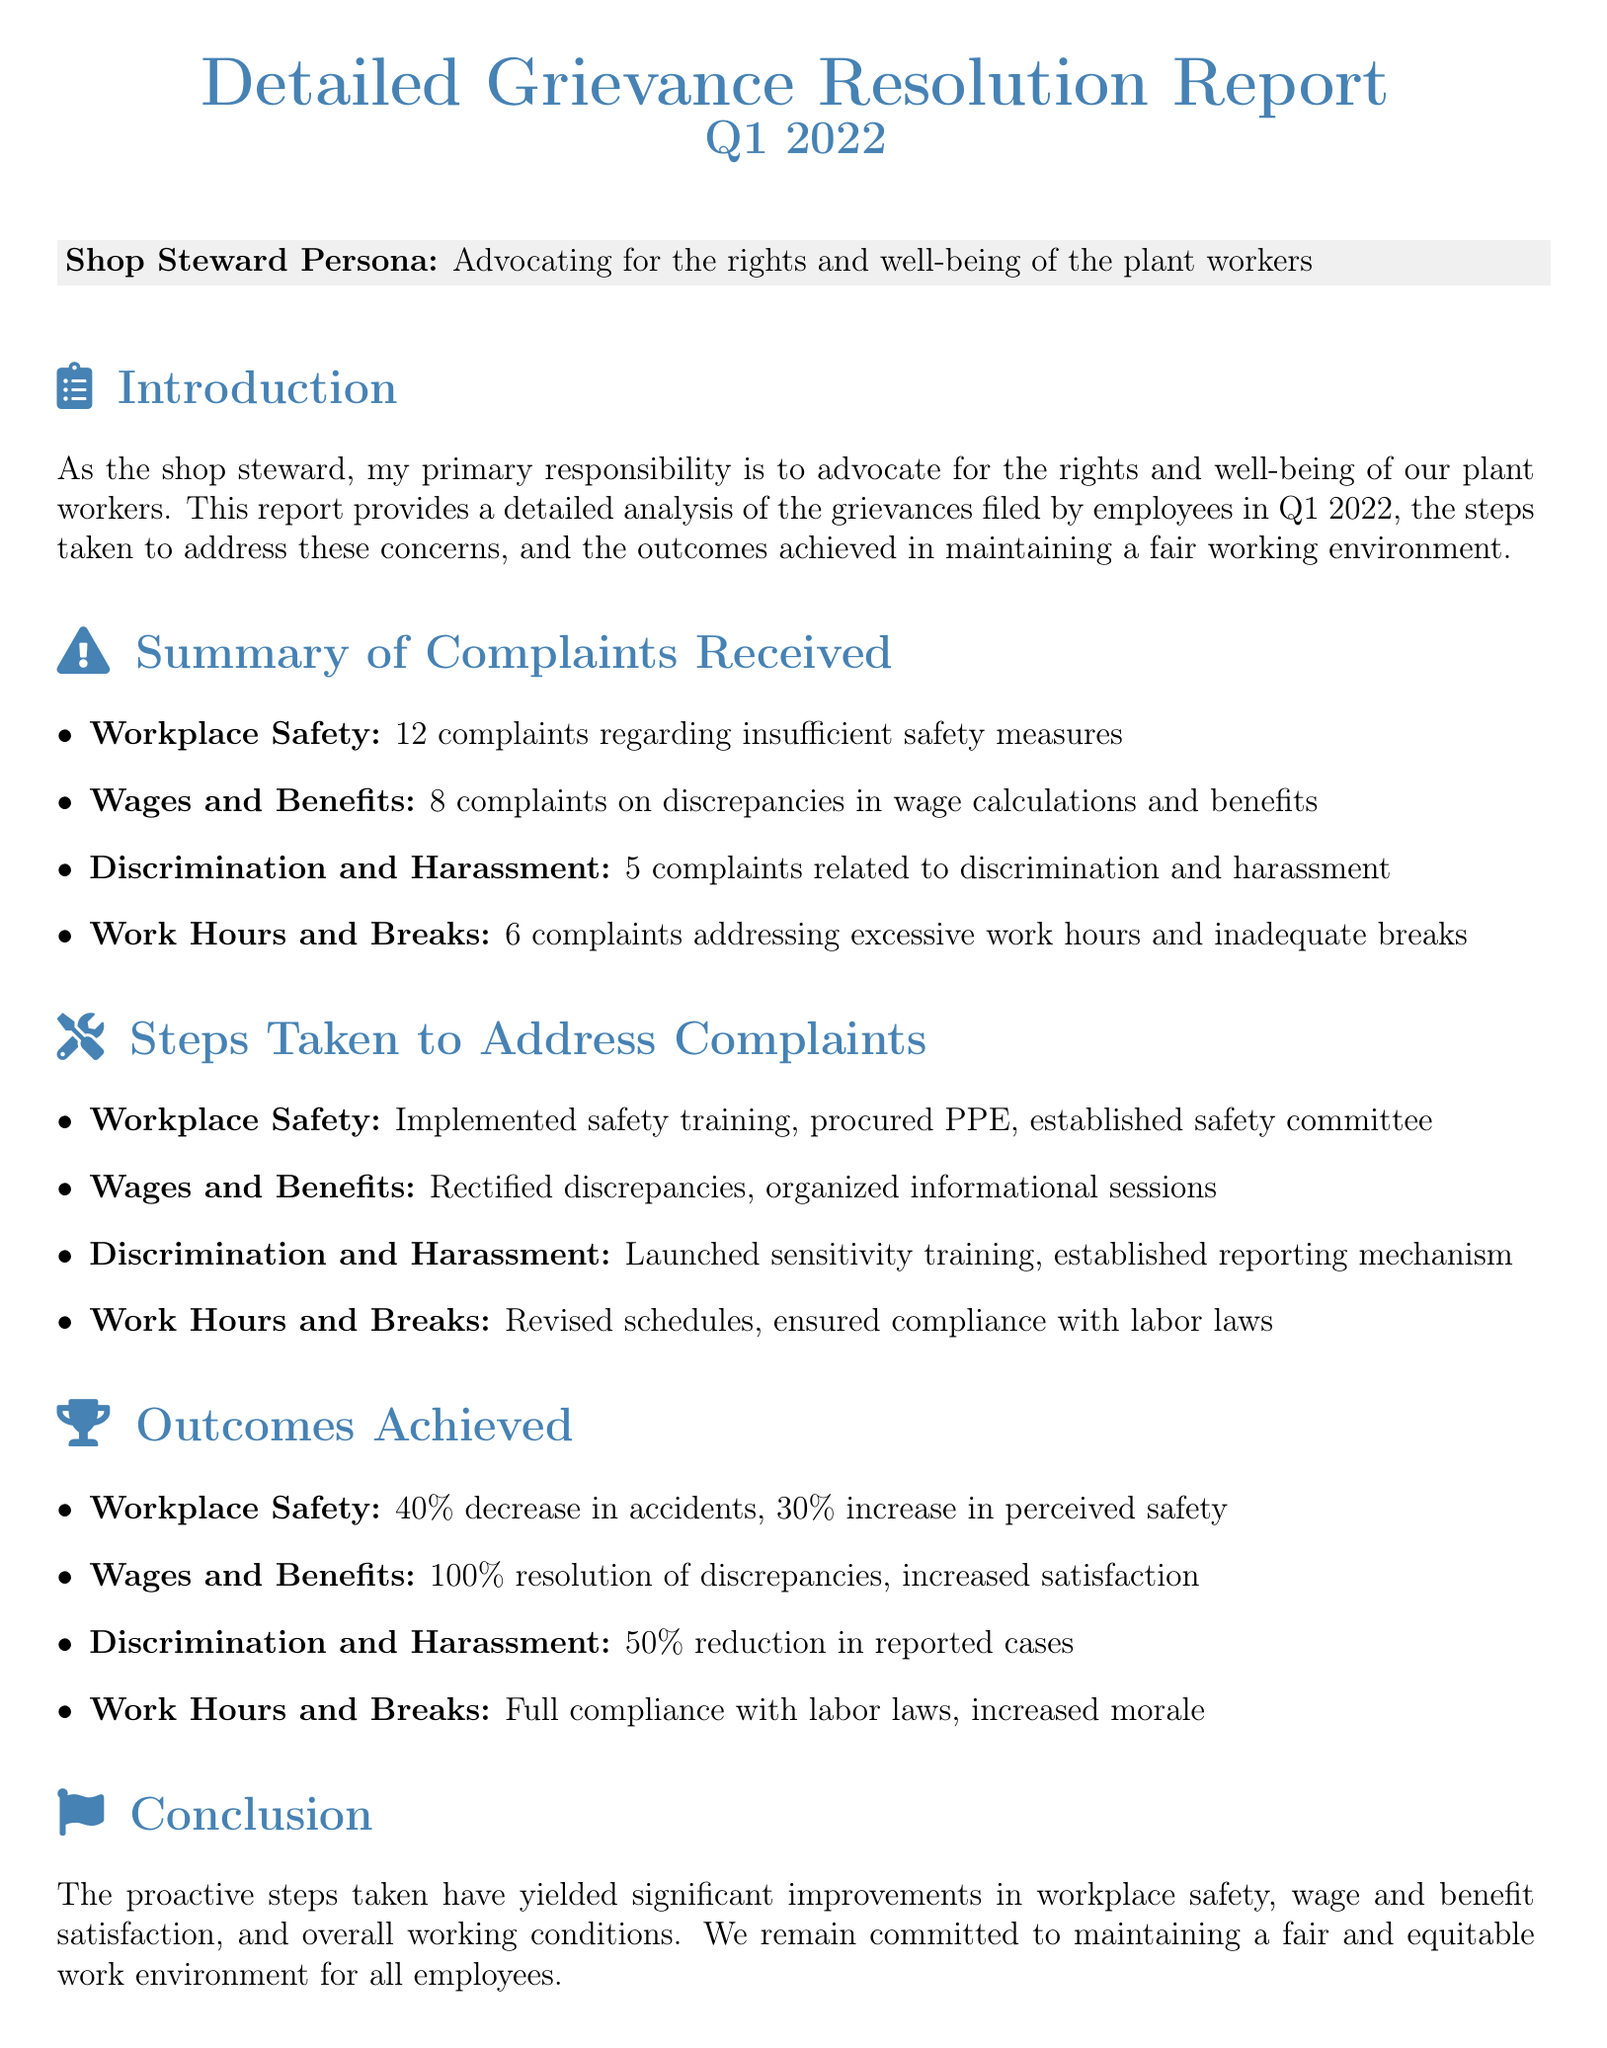What is the total number of complaints received? The total number of complaints is calculated by adding the individual complaints in various categories: 12 (Workplace Safety) + 8 (Wages and Benefits) + 5 (Discrimination and Harassment) + 6 (Work Hours and Breaks) = 31.
Answer: 31 How many complaints were related to workplace safety? The document specifies that there were 12 complaints regarding workplace safety.
Answer: 12 What percentage decrease in accidents was achieved? The outcomes section states there was a 40% decrease in accidents.
Answer: 40% How many complaints pertained to discrimination and harassment? The report mentions that there were 5 complaints related to discrimination and harassment.
Answer: 5 What steps were taken for wages and benefits complaints? The document lists that discrepancies were rectified and informational sessions were organized to address wages and benefits complaints.
Answer: Rectified discrepancies, organized informational sessions What was the outcome regarding the resolution of wage discrepancies? The report states that there was a 100% resolution of discrepancies in wages and benefits.
Answer: 100% What kind of training was launched to address discrimination and harassment? The report mentions that sensitivity training was launched to address this issue.
Answer: Sensitivity training What was the result for work hours and breaks complaints? The report indicates that there was full compliance with labor laws and increased morale regarding work hours and breaks.
Answer: Full compliance with labor laws, increased morale 